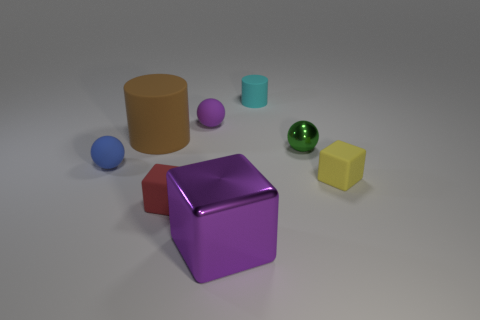Add 1 tiny red rubber cubes. How many objects exist? 9 Subtract all balls. How many objects are left? 5 Add 6 tiny cyan rubber cylinders. How many tiny cyan rubber cylinders exist? 7 Subtract 1 red cubes. How many objects are left? 7 Subtract all tiny blue matte things. Subtract all small yellow objects. How many objects are left? 6 Add 6 large metallic cubes. How many large metallic cubes are left? 7 